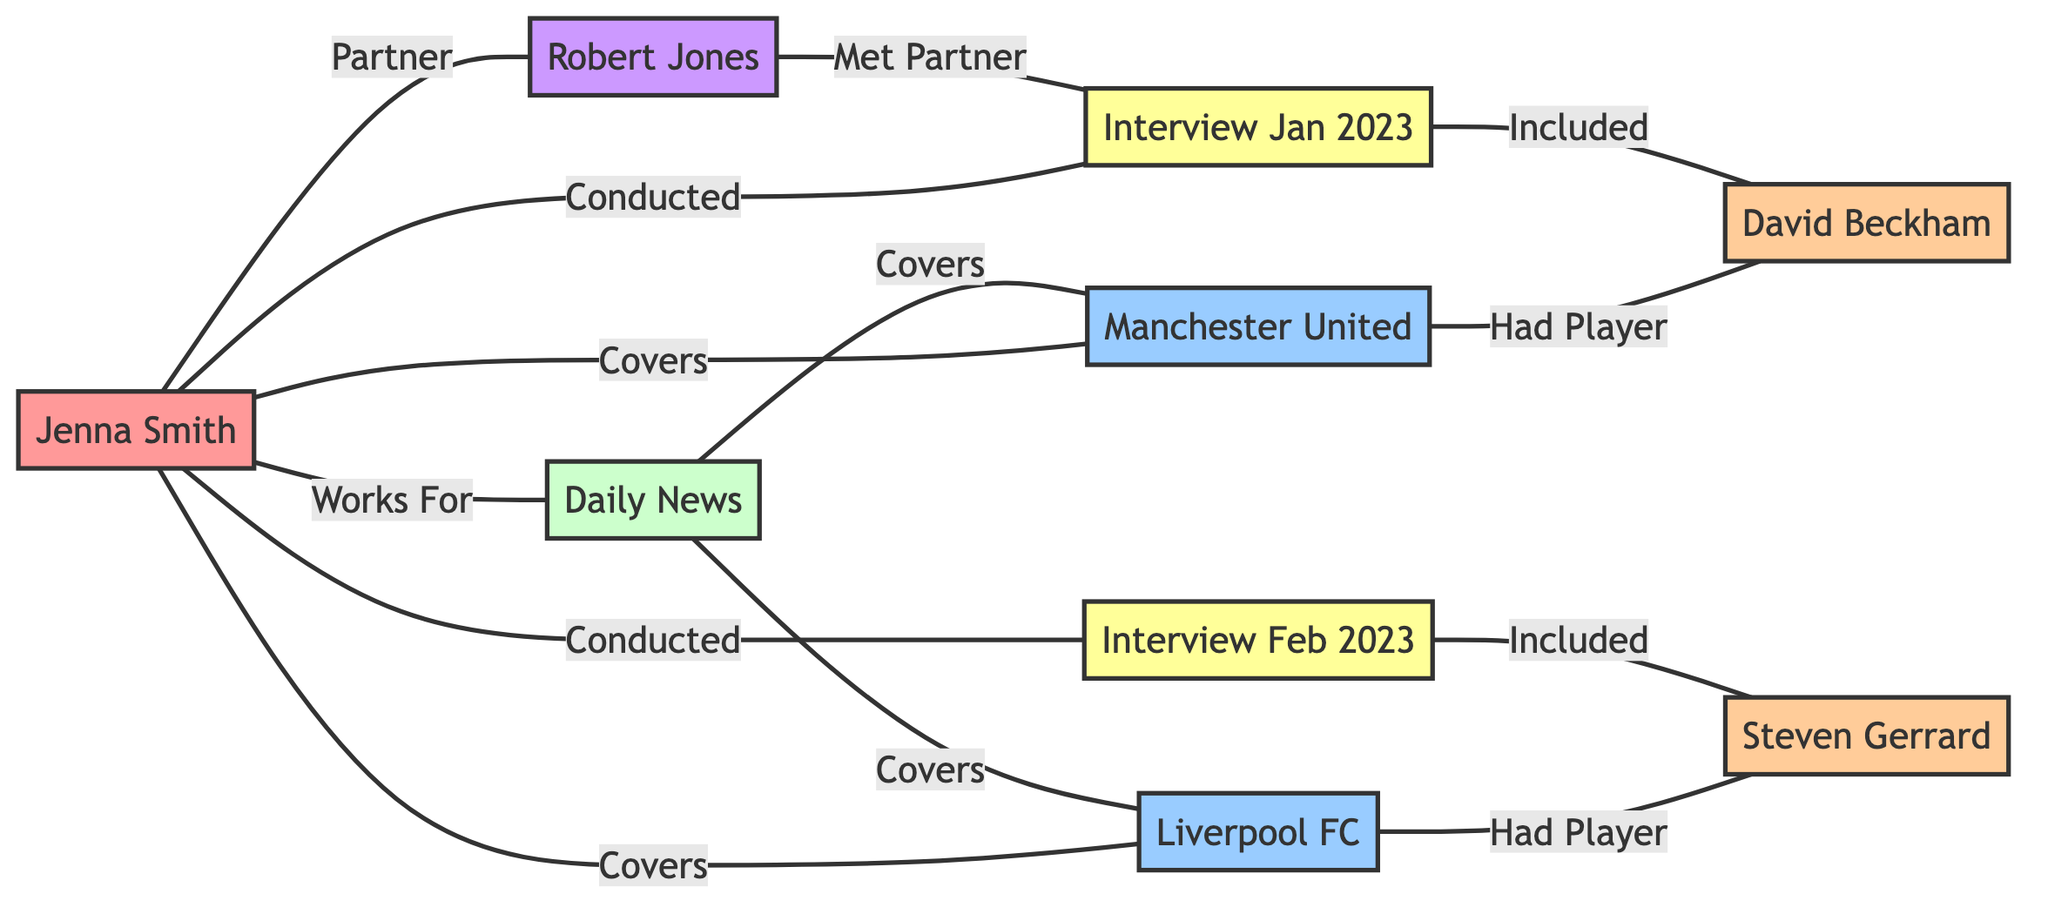What is the primary media outlet that Jenna Smith works for? In the diagram, Jenna Smith is directly connected to Daily News with the relationship "Works For," indicating that Daily News is the media outlet she is associated with.
Answer: Daily News How many soccer teams does Jenna Smith cover? Looking at the links connected to Jenna Smith, she has the relationships "Covers" with both Manchester United and Liverpool FC, which means she covers two soccer teams.
Answer: 2 Who is the player associated with Manchester United in the diagram? The diagram shows that Manchester United has a link to David Beckham with the relationship "Had Player," indicating that David Beckham is the player associated with that soccer team.
Answer: David Beckham What interviews did Jenna Smith conduct in January and February 2023? The links connected to Jenna Smith labeled "Conducted" show two interviews: Interview January 2023 and Interview February 2023. This indicates the specific interviews she carried out during those months.
Answer: Interview January 2023, Interview February 2023 How is Robert Jones connected to Jenna Smith? According to the diagram, Robert Jones is linked to Jenna Smith with the relationship "Partner," which indicates that Robert Jones is her partner.
Answer: Partner Which player did Jenna Smith include in the January interview? The Interview January 2023 is linked to David Beckham with the relationship "Included," indicating that David Beckham was featured in the interview conducted by Jenna Smith.
Answer: David Beckham What is the total number of nodes in the diagram? By counting the distinct nodes listed, there are 9 nodes in total, which includes reporters, media outlets, teams, players, interviews, and partners.
Answer: 9 Which soccer team has Steven Gerrard as a player? The diagram shows Liverpool FC has a link to Steven Gerrard with the relationship "Had Player," indicating that Steven Gerrard is the player associated with Liverpool FC.
Answer: Liverpool FC In which interview did Robert Jones meet Jenna Smith? The diagram indicates that Robert Jones is linked to the Interview January 2023 with the relationship "Met Partner," indicating he met Jenna Smith during that interview.
Answer: Interview January 2023 